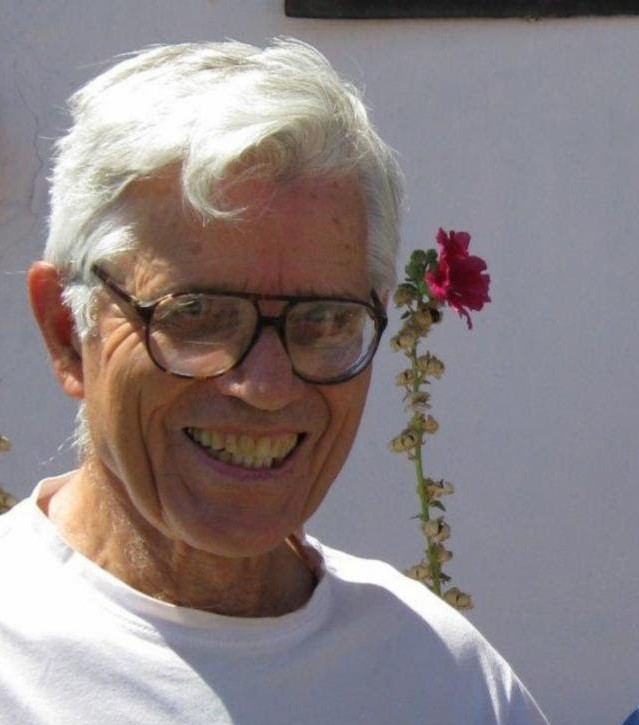What type of flower appears to be playfully positioned atop the man's head, and what does its condition tell us about how long it might have been picked? The flower perched atop the man's head looks like a vibrant red carnation. The condition of the flower appears quite fresh and well-maintained, indicating it was likely picked recently. The presence of smaller, wilted flowers and leaves along the stem suggests that while the primary bloom is in good shape, other parts are starting to wither, which might mean the carnation was picked within the last one or two days, possibly within this short time frame it has started showing signs of wear but still holds significant freshness. 